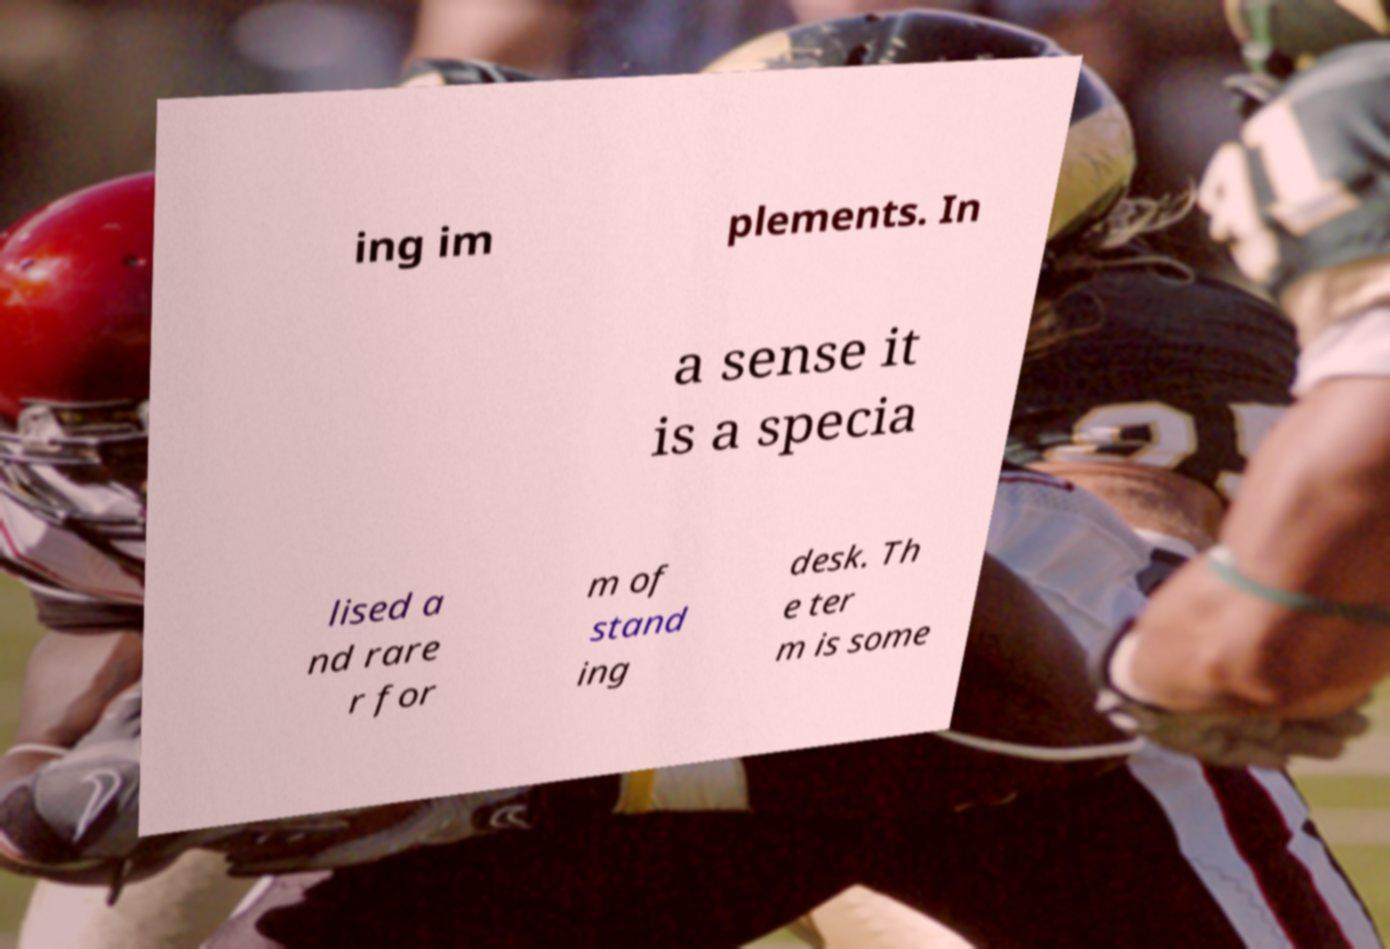Could you assist in decoding the text presented in this image and type it out clearly? ing im plements. In a sense it is a specia lised a nd rare r for m of stand ing desk. Th e ter m is some 